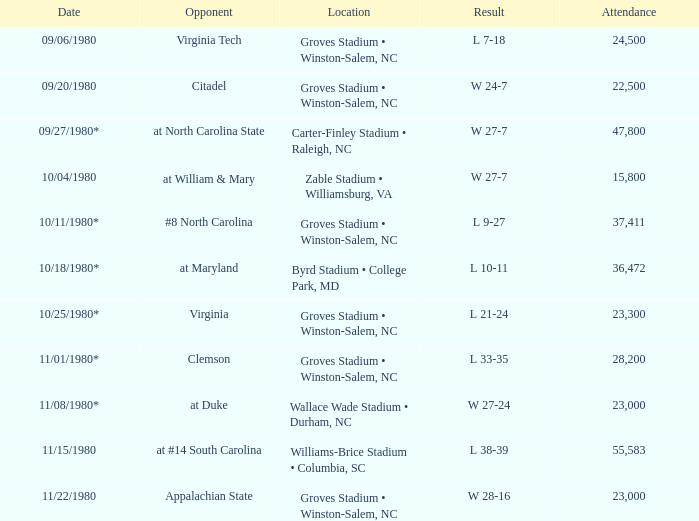How many people attended when Wake Forest played Virginia Tech? 24500.0. 